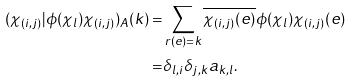Convert formula to latex. <formula><loc_0><loc_0><loc_500><loc_500>( \chi _ { ( i , j ) } | \phi ( \chi _ { l } ) \chi _ { ( i , j ) } ) _ { A } ( k ) = & \sum _ { r ( e ) = k } \overline { \chi _ { ( i , j ) } ( e ) } \phi ( \chi _ { l } ) \chi _ { ( i , j ) } ( e ) \\ = & \delta _ { l , i } \delta _ { j , k } a _ { k , l } .</formula> 